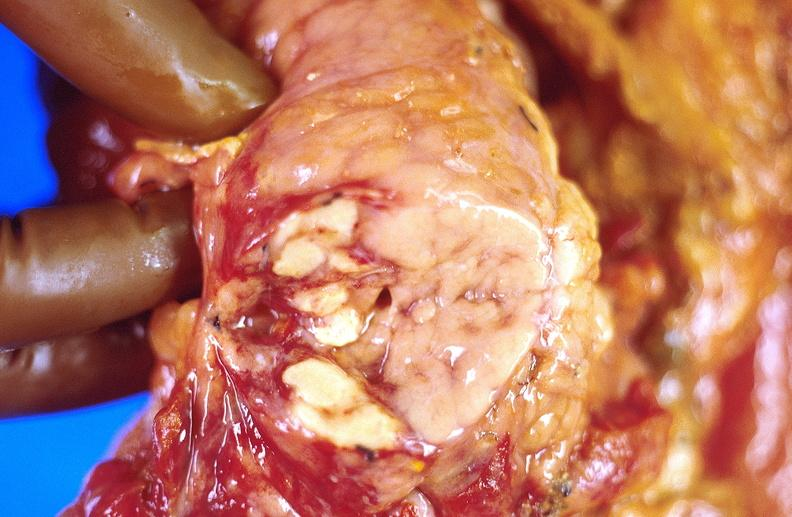what does this image show?
Answer the question using a single word or phrase. Pancreatic fat necrosis 